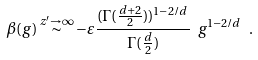<formula> <loc_0><loc_0><loc_500><loc_500>\beta ( g ) \overset { z ^ { \prime } \to \infty } { \sim } - \varepsilon \frac { ( \Gamma ( \frac { d { + } 2 } { 2 } ) ) ^ { 1 - 2 / d } } { \Gamma ( \frac { d } { 2 } ) } \ g ^ { 1 - 2 / d } \ .</formula> 